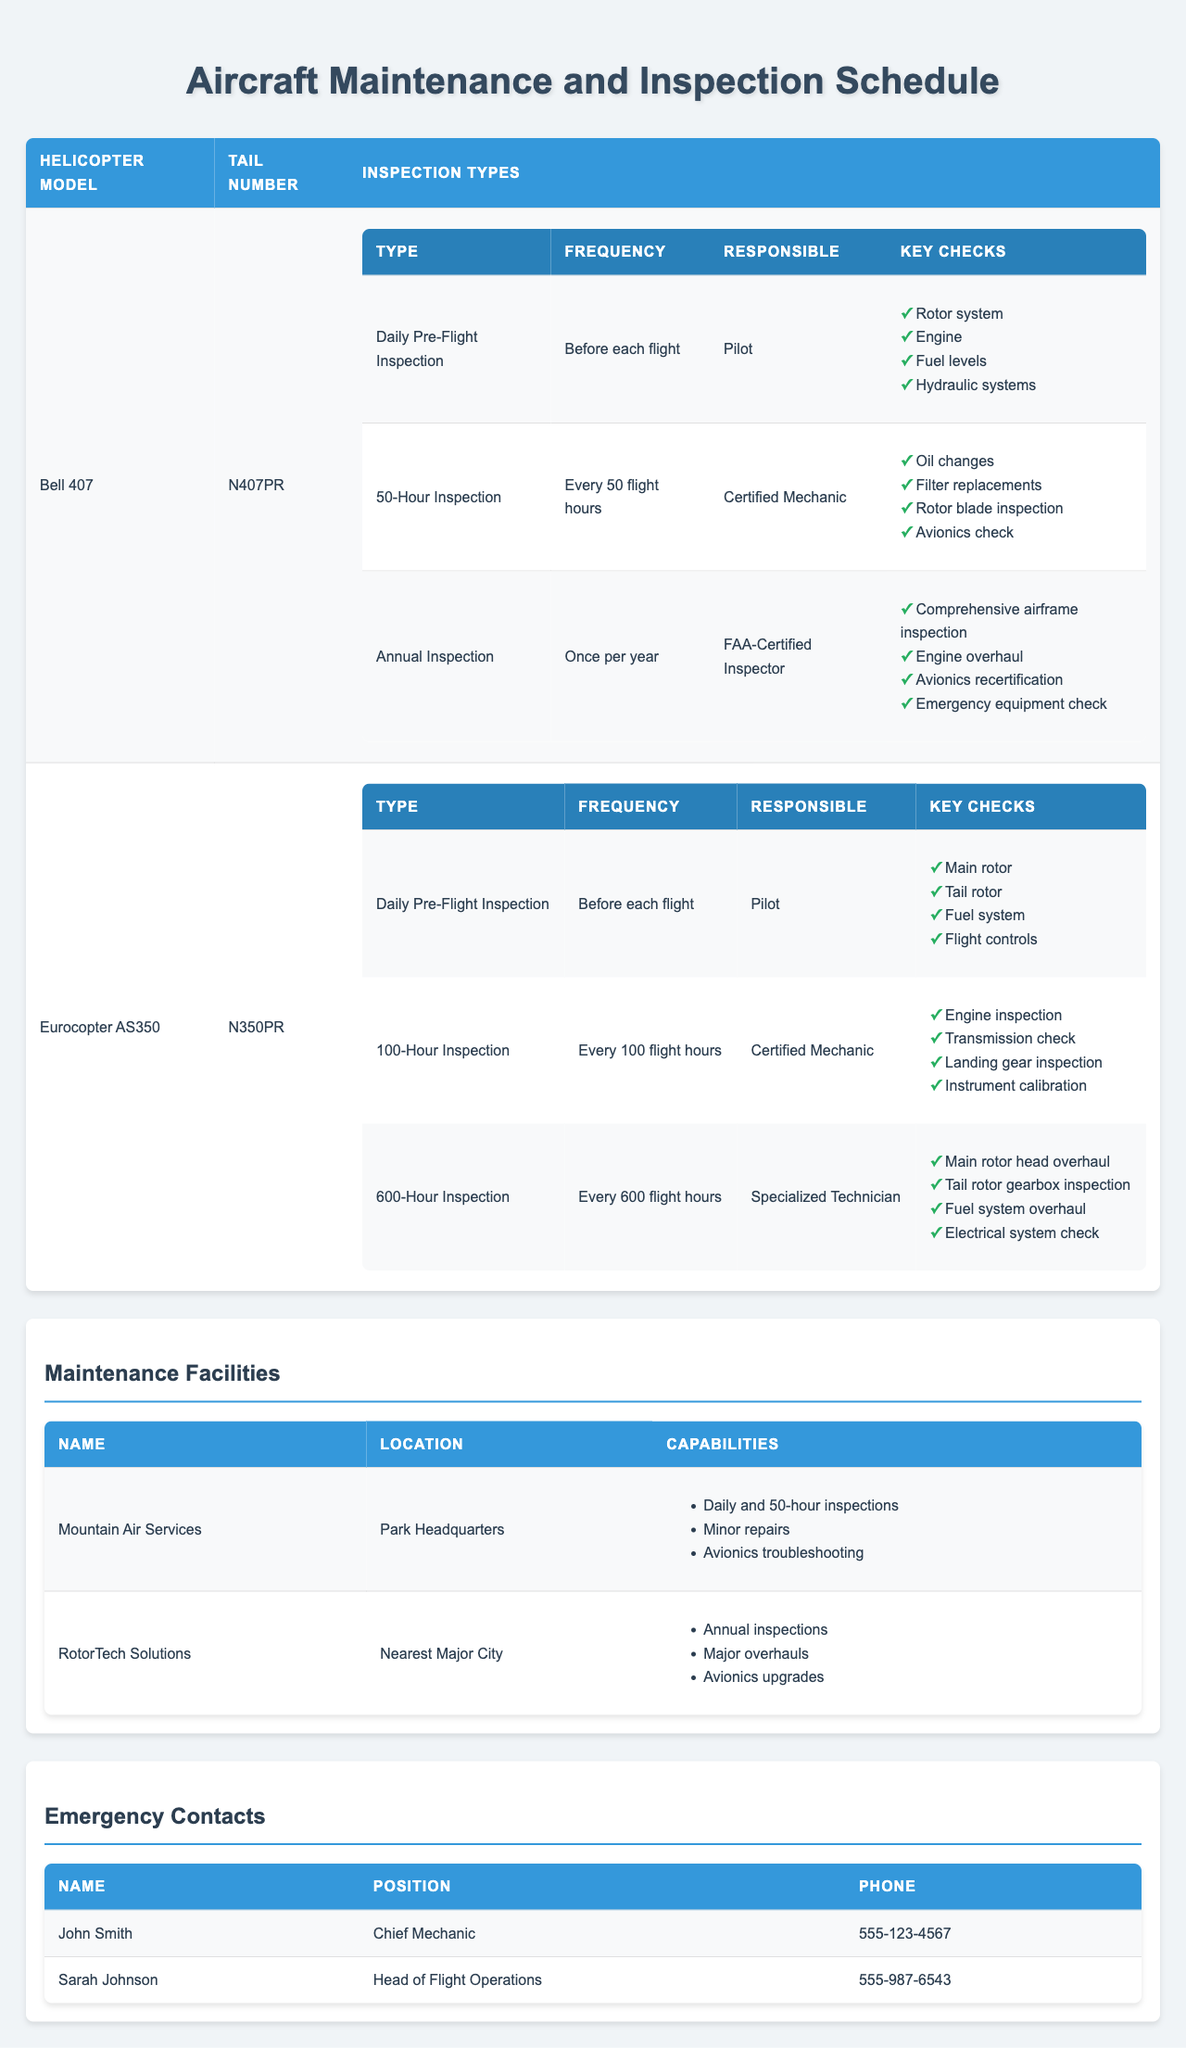What is the tail number for the Bell 407 helicopter? The table lists the tail number for the Bell 407 helicopter as N407PR.
Answer: N407PR How often is the 50-Hour Inspection performed for the Bell 407? According to the table, the 50-Hour Inspection for the Bell 407 is performed every 50 flight hours.
Answer: Every 50 flight hours Who is responsible for the Daily Pre-Flight Inspection of the Eurocopter AS350? The table states that the Pilot is responsible for the Daily Pre-Flight Inspection of the Eurocopter AS350.
Answer: Pilot What are the key checks for the Annual Inspection of the Bell 407? The table lists the key checks for the Annual Inspection of the Bell 407 as: Comprehensive airframe inspection, Engine overhaul, Avionics recertification, and Emergency equipment check.
Answer: Comprehensive airframe inspection, Engine overhaul, Avionics recertification, Emergency equipment check Is Mountain Air Services located at the Park Headquarters? The table confirms that Mountain Air Services is located at the Park Headquarters.
Answer: Yes What is the frequency of the 600-Hour Inspection for the Eurocopter AS350? The table shows that the 600-Hour Inspection for the Eurocopter AS350 is performed every 600 flight hours.
Answer: Every 600 flight hours List all the key checks involved in the 100-Hour Inspection for the Eurocopter AS350. The table highlights the key checks in the 100-Hour Inspection for the Eurocopter AS350 as: Engine inspection, Transmission check, Landing gear inspection, Instrument calibration.
Answer: Engine inspection, Transmission check, Landing gear inspection, Instrument calibration Which maintenance facility is responsible for annual inspections? The table indicates that RotorTech Solutions is responsible for annual inspections.
Answer: RotorTech Solutions How many inspection types are there for each helicopter model? The table shows that there are three inspection types for the Bell 407 and three for the Eurocopter AS350, making a total of six inspection types across both models.
Answer: Six inspection types What are the capabilities of the maintenance facility located in the nearest major city? The table lists the capabilities of RotorTech Solutions, located in the nearest major city, as: Annual inspections, Major overhauls, Avionics upgrades.
Answer: Annual inspections, Major overhauls, Avionics upgrades What is the relationship between inspection frequency and responsible personnel for the Bell 407 50-Hour Inspection? For the Bell 407, the 50-Hour Inspection is performed every 50 flight hours and is the responsibility of a Certified Mechanic, indicating that regular maintenance is crucial for safety and operational efficiency.
Answer: Certified Mechanic If the Bell 407 has completed 150 flight hours, how many 50-Hour Inspections have been performed? Since the 50-Hour Inspection is performed every 50 flight hours, if the Bell 407 has completed 150 flight hours, it would have undergone 3 inspections (150/50 = 3).
Answer: 3 inspections Are there any specialized technicians responsible for inspections? Yes, the table indicates that specialized technicians are responsible for the 600-Hour Inspection of the Eurocopter AS350.
Answer: Yes 